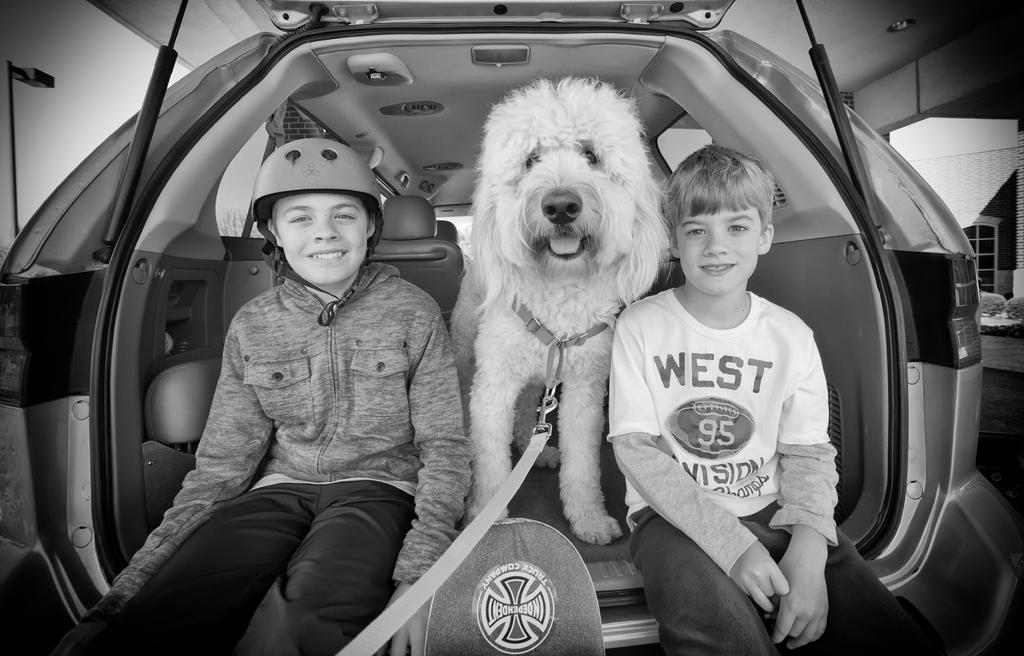How many people are in the image? There are two persons in the image. What are the two persons doing in the image? The two persons are sitting in a vehicle. Is there any animal present in the image? Yes, there is a dog in the vehicle. How is the dog secured in the vehicle? The dog has a leash. What type of work is the dog doing in the image? The image does not show the dog performing any work; it is simply present in the vehicle with a leash. What thoughts are going through the dog's mind in the image? The image does not provide any information about the dog's thoughts or mental state. 